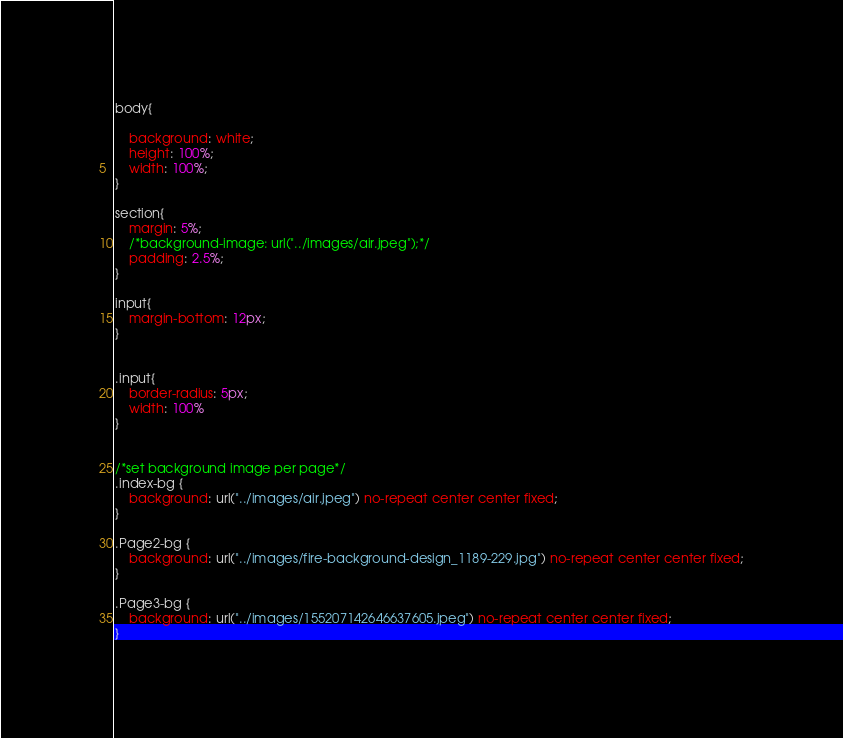Convert code to text. <code><loc_0><loc_0><loc_500><loc_500><_CSS_>body{

    background: white;
    height: 100%;
    width: 100%;
}

section{
    margin: 5%;
    /*background-image: url("../images/air.jpeg");*/
    padding: 2.5%;
}

input{
    margin-bottom: 12px;
}


.input{
    border-radius: 5px;
    width: 100%
}


/*set background image per page*/
.index-bg {
    background: url("../images/air.jpeg") no-repeat center center fixed;
}

.Page2-bg {
    background: url("../images/fire-background-design_1189-229.jpg") no-repeat center center fixed;
}

.Page3-bg {
    background: url("../images/155207142646637605.jpeg") no-repeat center center fixed;
}
</code> 